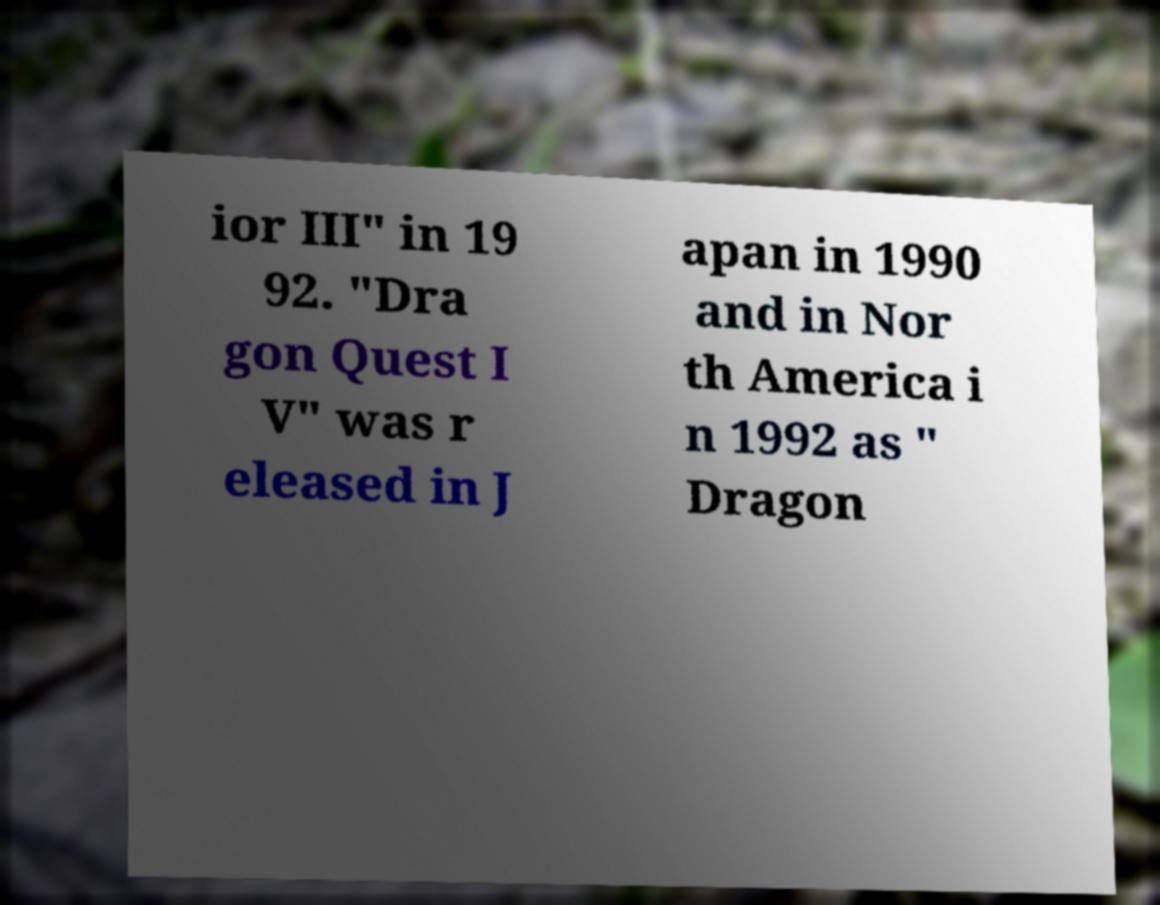I need the written content from this picture converted into text. Can you do that? ior III" in 19 92. "Dra gon Quest I V" was r eleased in J apan in 1990 and in Nor th America i n 1992 as " Dragon 